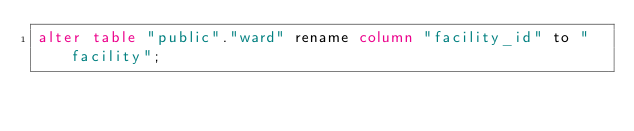<code> <loc_0><loc_0><loc_500><loc_500><_SQL_>alter table "public"."ward" rename column "facility_id" to "facility";
</code> 